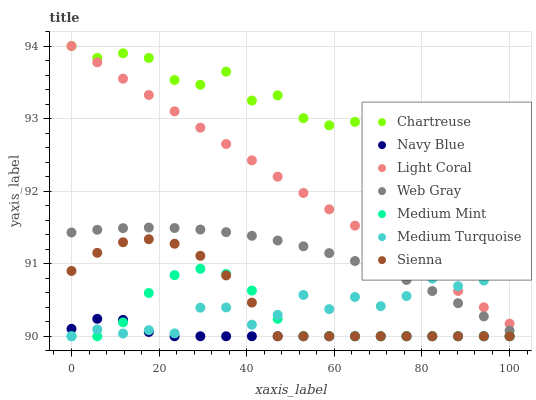Does Navy Blue have the minimum area under the curve?
Answer yes or no. Yes. Does Chartreuse have the maximum area under the curve?
Answer yes or no. Yes. Does Sienna have the minimum area under the curve?
Answer yes or no. No. Does Sienna have the maximum area under the curve?
Answer yes or no. No. Is Light Coral the smoothest?
Answer yes or no. Yes. Is Medium Turquoise the roughest?
Answer yes or no. Yes. Is Sienna the smoothest?
Answer yes or no. No. Is Sienna the roughest?
Answer yes or no. No. Does Medium Mint have the lowest value?
Answer yes or no. Yes. Does Web Gray have the lowest value?
Answer yes or no. No. Does Chartreuse have the highest value?
Answer yes or no. Yes. Does Sienna have the highest value?
Answer yes or no. No. Is Medium Mint less than Light Coral?
Answer yes or no. Yes. Is Web Gray greater than Navy Blue?
Answer yes or no. Yes. Does Light Coral intersect Medium Turquoise?
Answer yes or no. Yes. Is Light Coral less than Medium Turquoise?
Answer yes or no. No. Is Light Coral greater than Medium Turquoise?
Answer yes or no. No. Does Medium Mint intersect Light Coral?
Answer yes or no. No. 